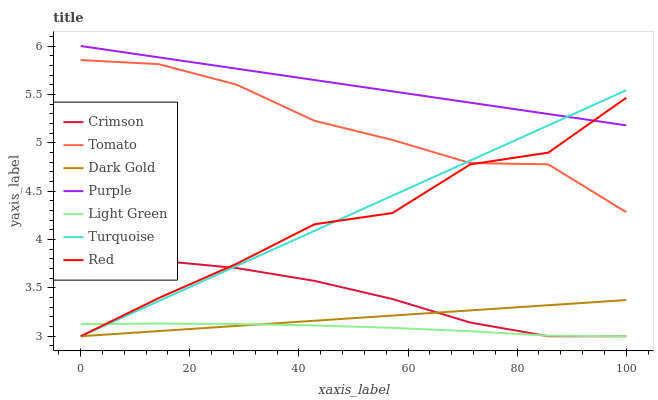Does Light Green have the minimum area under the curve?
Answer yes or no. Yes. Does Purple have the maximum area under the curve?
Answer yes or no. Yes. Does Turquoise have the minimum area under the curve?
Answer yes or no. No. Does Turquoise have the maximum area under the curve?
Answer yes or no. No. Is Dark Gold the smoothest?
Answer yes or no. Yes. Is Red the roughest?
Answer yes or no. Yes. Is Turquoise the smoothest?
Answer yes or no. No. Is Turquoise the roughest?
Answer yes or no. No. Does Turquoise have the lowest value?
Answer yes or no. Yes. Does Purple have the lowest value?
Answer yes or no. No. Does Purple have the highest value?
Answer yes or no. Yes. Does Turquoise have the highest value?
Answer yes or no. No. Is Crimson less than Purple?
Answer yes or no. Yes. Is Purple greater than Dark Gold?
Answer yes or no. Yes. Does Red intersect Crimson?
Answer yes or no. Yes. Is Red less than Crimson?
Answer yes or no. No. Is Red greater than Crimson?
Answer yes or no. No. Does Crimson intersect Purple?
Answer yes or no. No. 